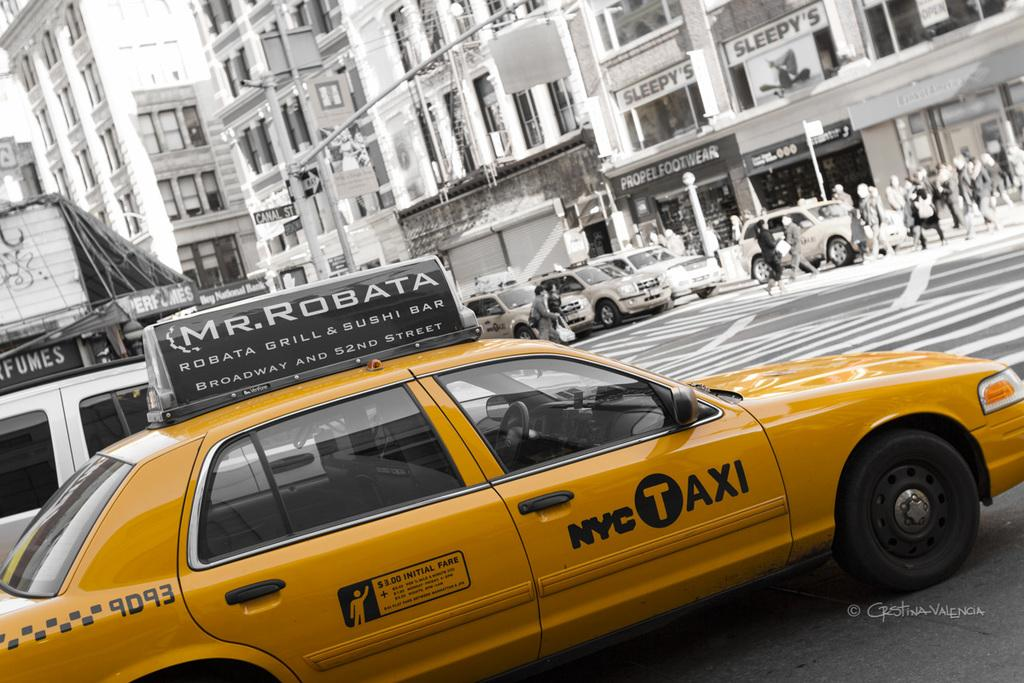<image>
Write a terse but informative summary of the picture. A yellow taxi cab that says mr robata on the top of it. 